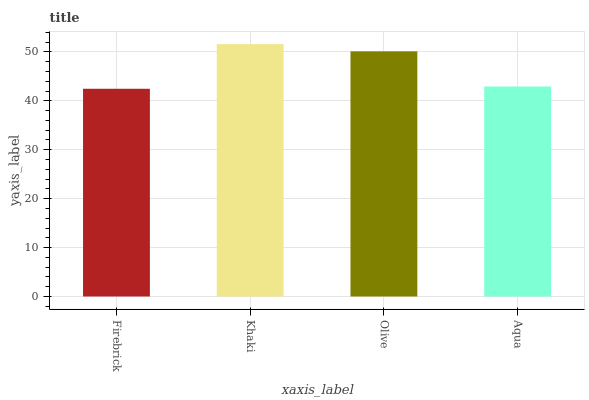Is Firebrick the minimum?
Answer yes or no. Yes. Is Khaki the maximum?
Answer yes or no. Yes. Is Olive the minimum?
Answer yes or no. No. Is Olive the maximum?
Answer yes or no. No. Is Khaki greater than Olive?
Answer yes or no. Yes. Is Olive less than Khaki?
Answer yes or no. Yes. Is Olive greater than Khaki?
Answer yes or no. No. Is Khaki less than Olive?
Answer yes or no. No. Is Olive the high median?
Answer yes or no. Yes. Is Aqua the low median?
Answer yes or no. Yes. Is Khaki the high median?
Answer yes or no. No. Is Firebrick the low median?
Answer yes or no. No. 